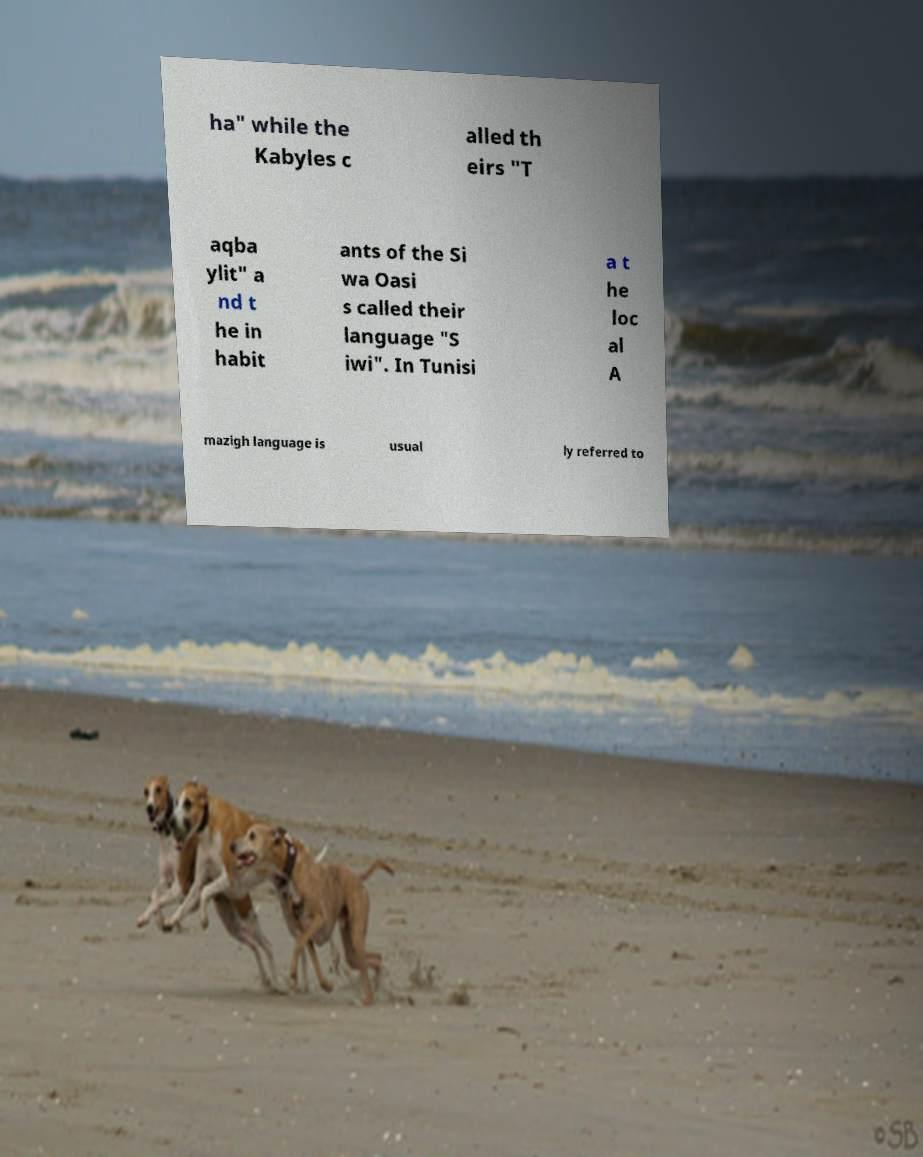I need the written content from this picture converted into text. Can you do that? ha" while the Kabyles c alled th eirs "T aqba ylit" a nd t he in habit ants of the Si wa Oasi s called their language "S iwi". In Tunisi a t he loc al A mazigh language is usual ly referred to 